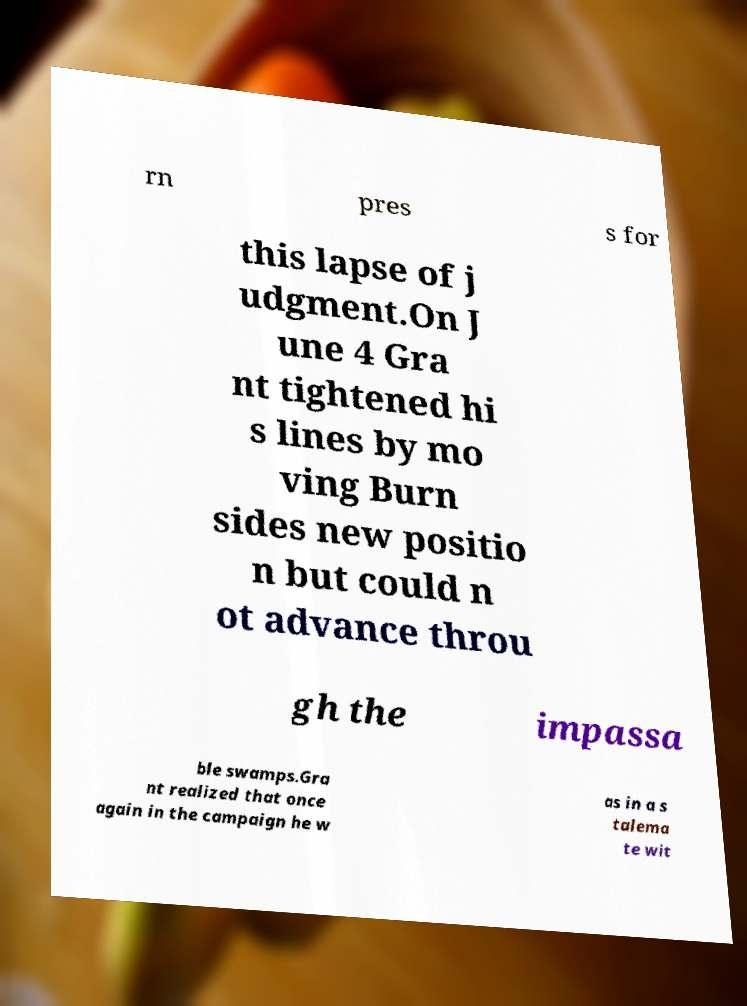Please read and relay the text visible in this image. What does it say? rn pres s for this lapse of j udgment.On J une 4 Gra nt tightened hi s lines by mo ving Burn sides new positio n but could n ot advance throu gh the impassa ble swamps.Gra nt realized that once again in the campaign he w as in a s talema te wit 